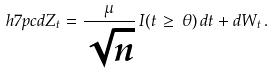<formula> <loc_0><loc_0><loc_500><loc_500>\ h { 7 p c } d Z _ { t } = \frac { \mu } { \sqrt { n } } \, I ( t \, \geq \, \theta ) \, d t + d W _ { t } \, .</formula> 